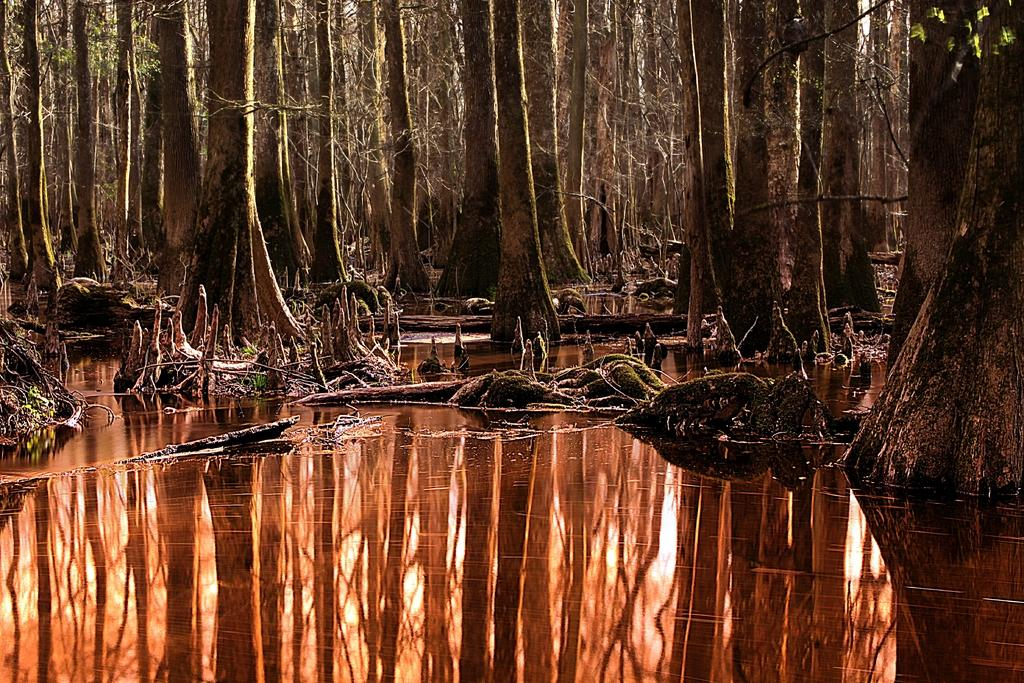What type of vegetation can be seen in the image? There are trees in the image. What natural element is also visible in the image? There is water visible in the image. What scientific discoveries are being discussed in the image? There is no indication of any scientific discussions or discoveries in the image; it simply features trees and water. What type of flowers can be seen growing near the trees in the image? There are no flowers visible in the image; only trees and water are present. 